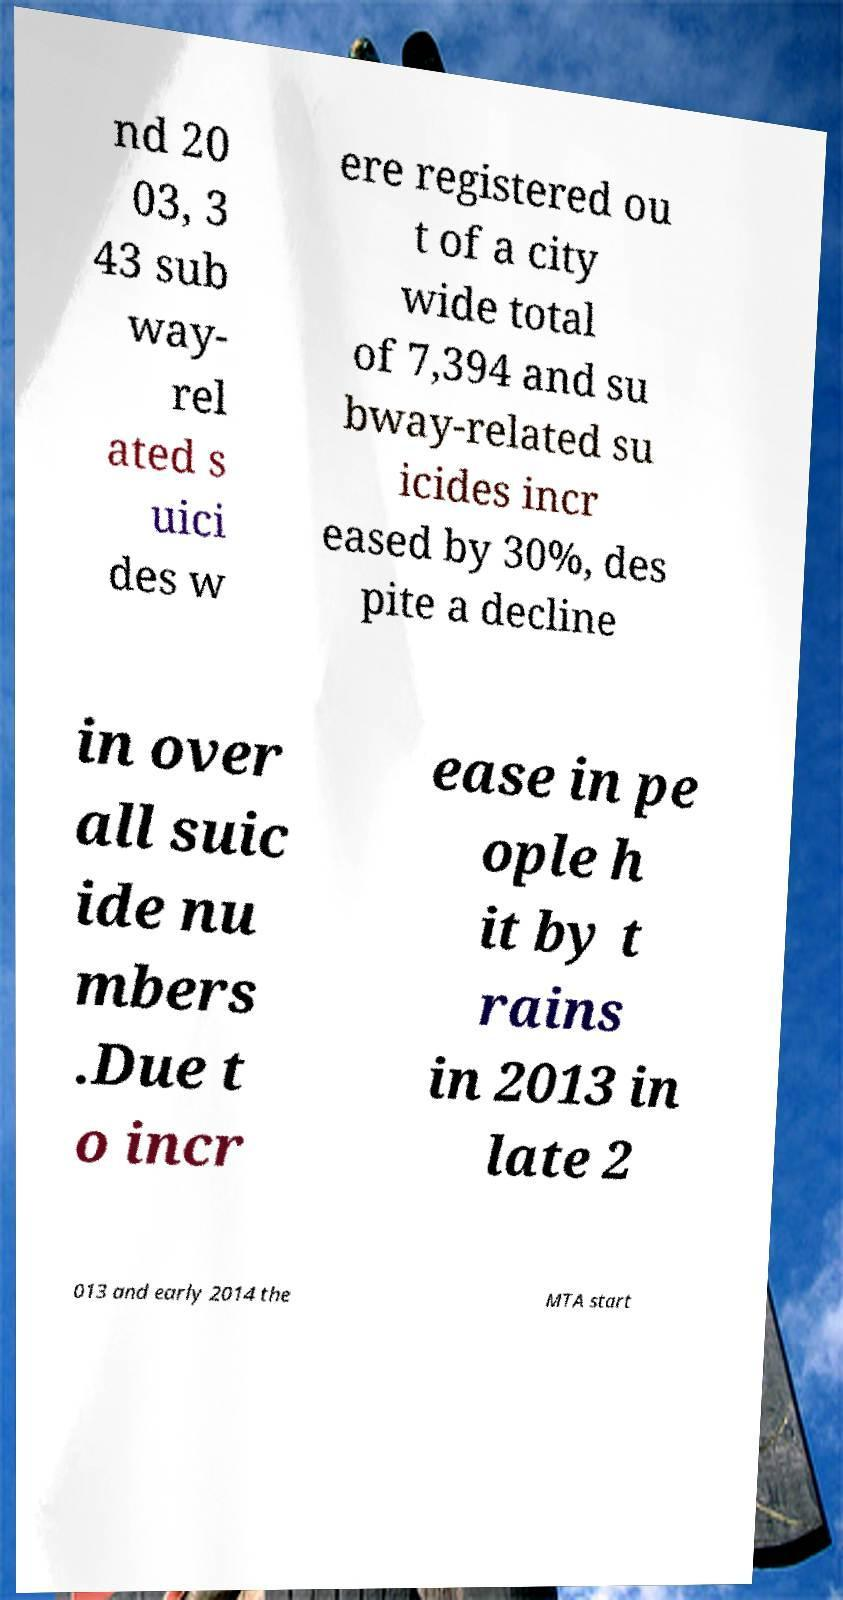Can you accurately transcribe the text from the provided image for me? nd 20 03, 3 43 sub way- rel ated s uici des w ere registered ou t of a city wide total of 7,394 and su bway-related su icides incr eased by 30%, des pite a decline in over all suic ide nu mbers .Due t o incr ease in pe ople h it by t rains in 2013 in late 2 013 and early 2014 the MTA start 